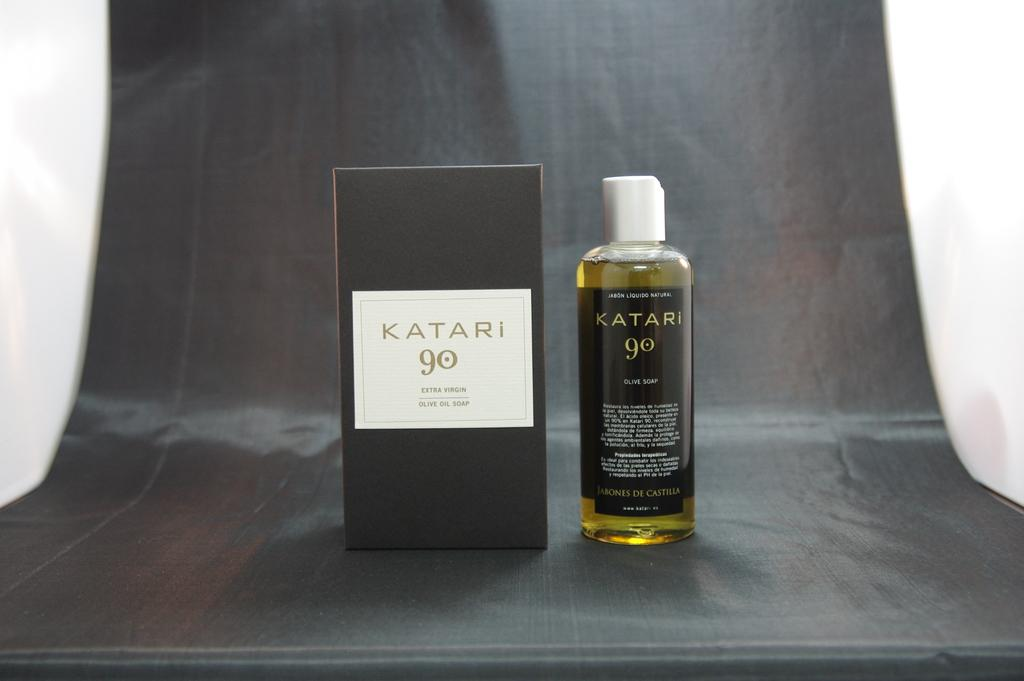<image>
Share a concise interpretation of the image provided. A bottle and a black box of Katari 90 